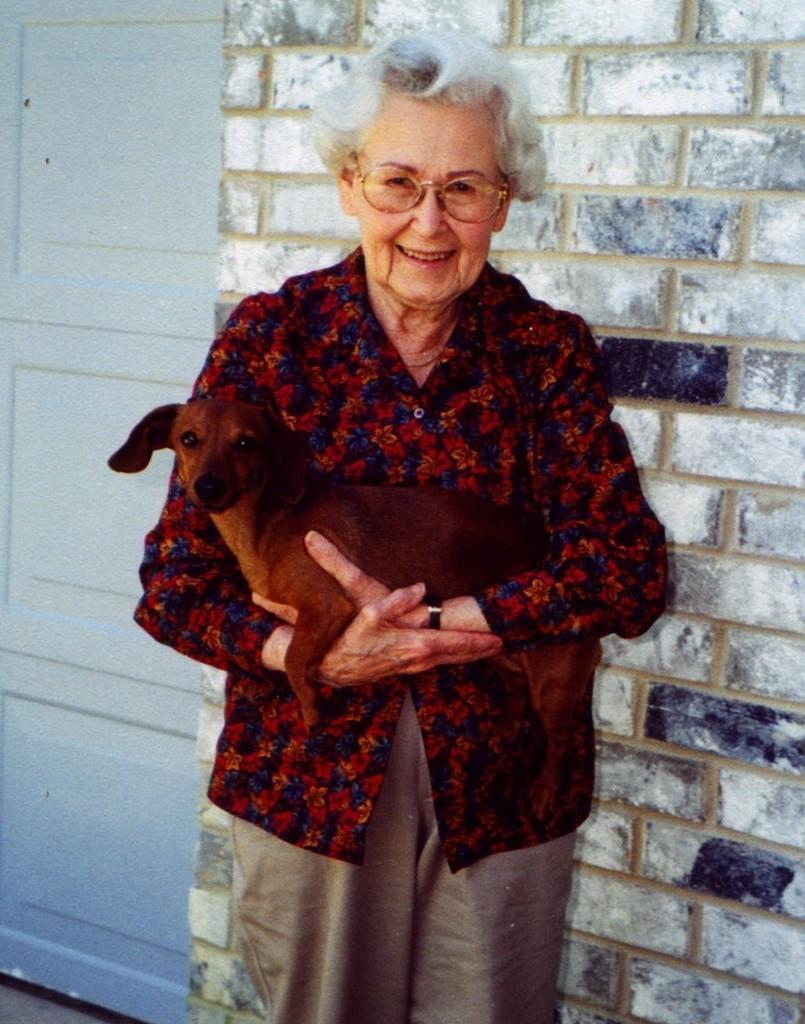What is the woman in the image doing? The woman is laughing in the image. What is the woman holding in the image? The woman is holding a dog in the image. What can be seen in the background of the image? There is a wall and a door in the background of the image. What type of shame can be seen on the woman's face in the image? There is no indication of shame on the woman's face in the image; she is laughing. Can you tell me how many geese are visible in the image? There are no geese present in the image. 